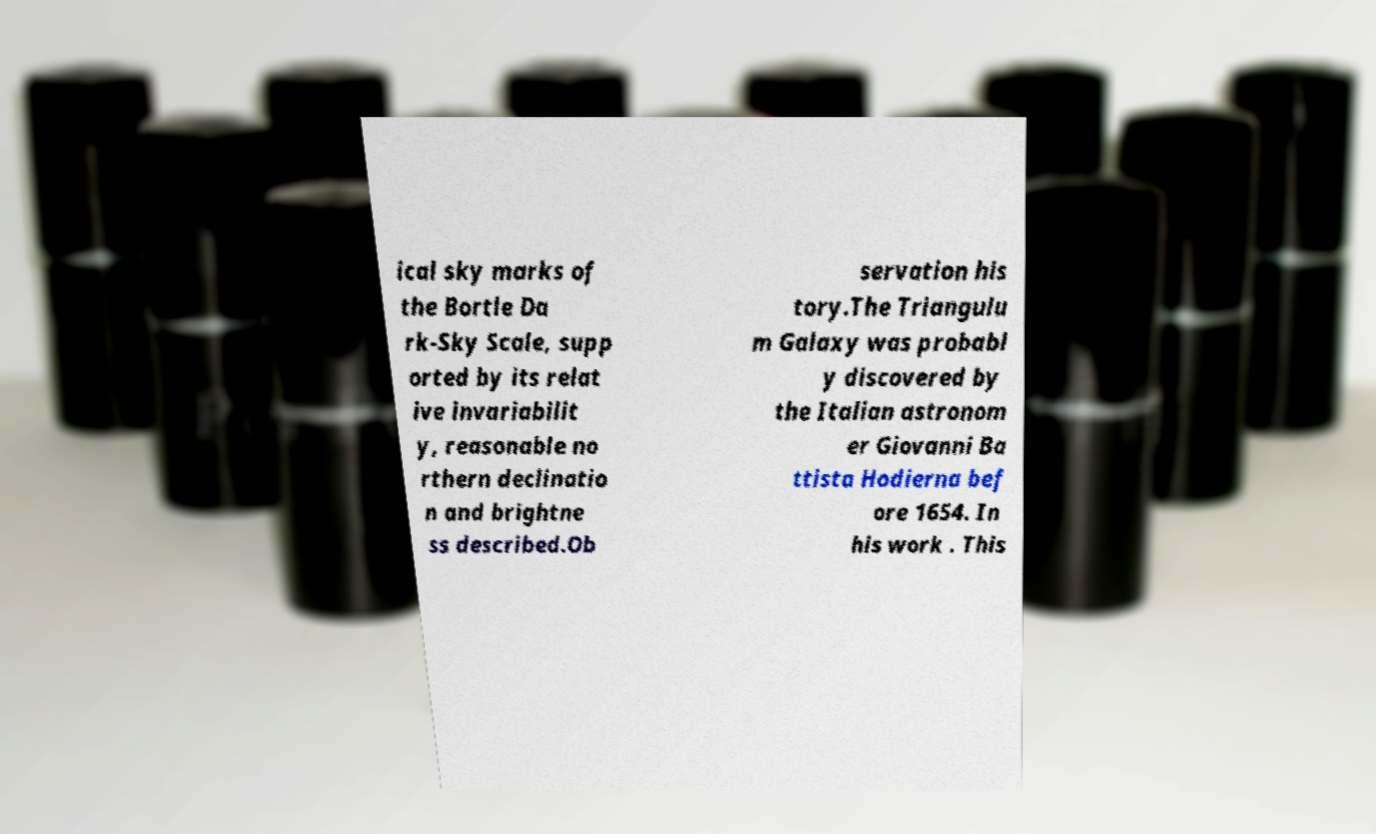Please identify and transcribe the text found in this image. ical sky marks of the Bortle Da rk-Sky Scale, supp orted by its relat ive invariabilit y, reasonable no rthern declinatio n and brightne ss described.Ob servation his tory.The Triangulu m Galaxy was probabl y discovered by the Italian astronom er Giovanni Ba ttista Hodierna bef ore 1654. In his work . This 